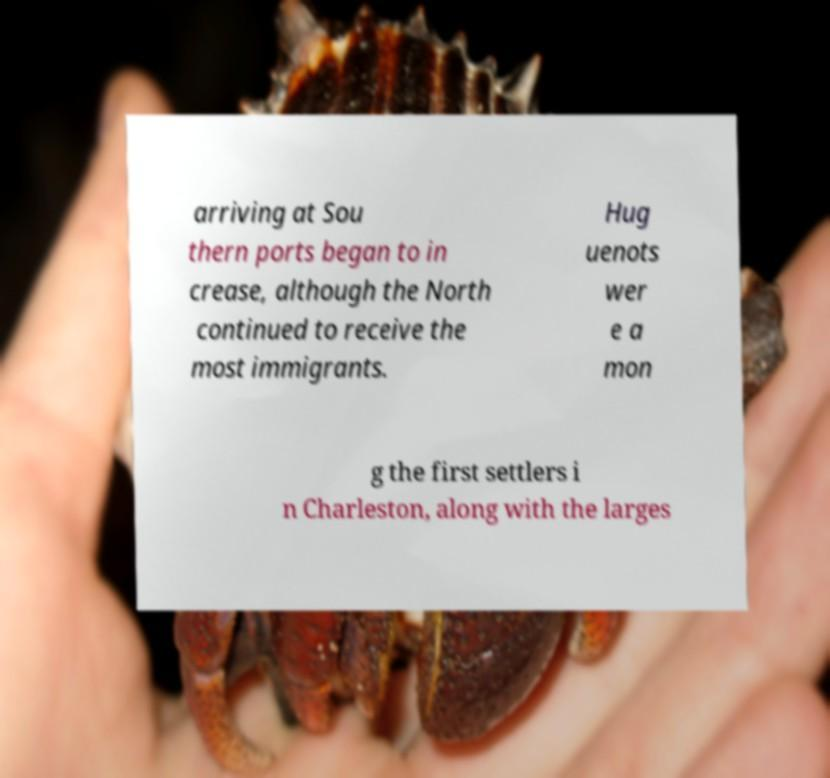Can you accurately transcribe the text from the provided image for me? arriving at Sou thern ports began to in crease, although the North continued to receive the most immigrants. Hug uenots wer e a mon g the first settlers i n Charleston, along with the larges 